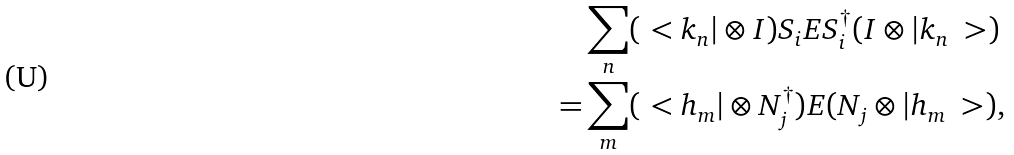<formula> <loc_0><loc_0><loc_500><loc_500>& \sum _ { n } ( \ < k _ { n } | \otimes I ) S _ { i } E S _ { i } ^ { \dag } ( I \otimes | k _ { n } \ > ) \\ = & \sum _ { m } ( \ < h _ { m } | \otimes N _ { j } ^ { \dag } ) E ( N _ { j } \otimes | h _ { m } \ > ) ,</formula> 